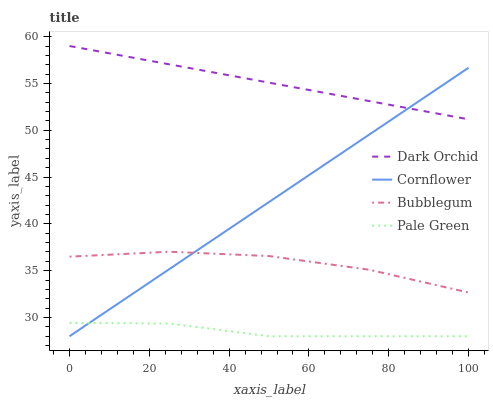Does Pale Green have the minimum area under the curve?
Answer yes or no. Yes. Does Dark Orchid have the maximum area under the curve?
Answer yes or no. Yes. Does Bubblegum have the minimum area under the curve?
Answer yes or no. No. Does Bubblegum have the maximum area under the curve?
Answer yes or no. No. Is Dark Orchid the smoothest?
Answer yes or no. Yes. Is Bubblegum the roughest?
Answer yes or no. Yes. Is Pale Green the smoothest?
Answer yes or no. No. Is Pale Green the roughest?
Answer yes or no. No. Does Bubblegum have the lowest value?
Answer yes or no. No. Does Dark Orchid have the highest value?
Answer yes or no. Yes. Does Bubblegum have the highest value?
Answer yes or no. No. Is Pale Green less than Dark Orchid?
Answer yes or no. Yes. Is Bubblegum greater than Pale Green?
Answer yes or no. Yes. Does Cornflower intersect Dark Orchid?
Answer yes or no. Yes. Is Cornflower less than Dark Orchid?
Answer yes or no. No. Is Cornflower greater than Dark Orchid?
Answer yes or no. No. Does Pale Green intersect Dark Orchid?
Answer yes or no. No. 